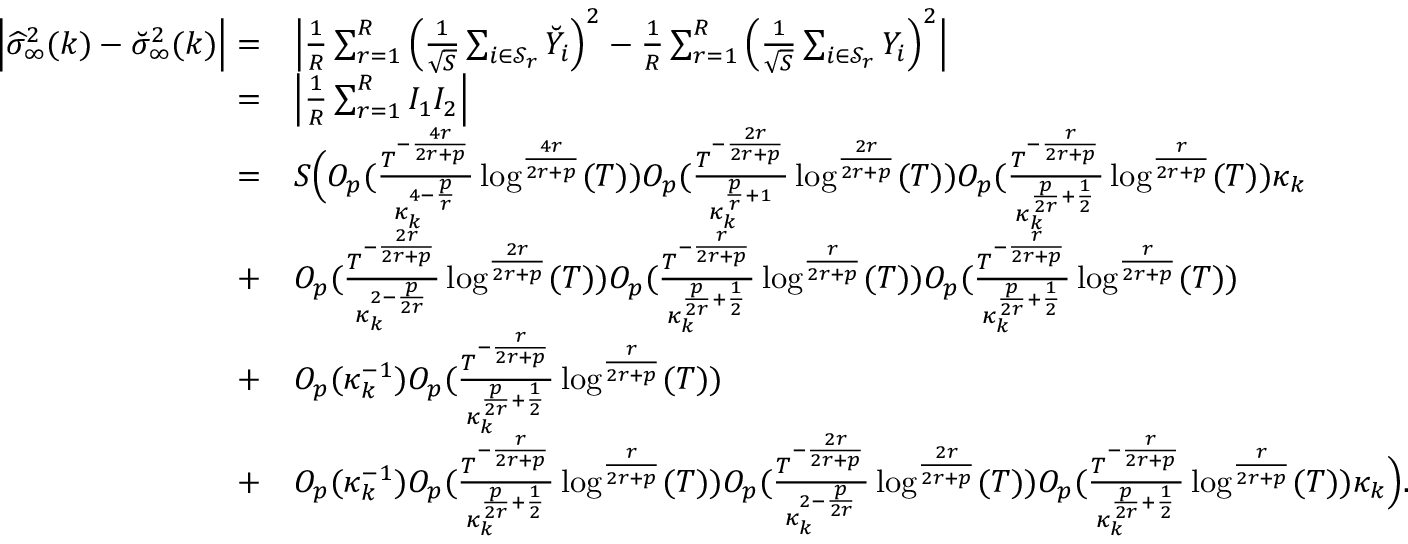<formula> <loc_0><loc_0><loc_500><loc_500>\begin{array} { r l } { \left | \widehat { \sigma } _ { \infty } ^ { 2 } ( k ) - \breve { \sigma } _ { \infty } ^ { 2 } ( k ) \right | = } & { \left | \frac { 1 } { R } \sum _ { r = 1 } ^ { R } \left ( \frac { 1 } { \sqrt { S } } \sum _ { i \in { \mathcal { S } _ { r } } } \breve { Y } _ { i } \right ) ^ { 2 } - \frac { 1 } { R } \sum _ { r = 1 } ^ { R } \left ( \frac { 1 } { \sqrt { S } } \sum _ { i \in { \mathcal { S } _ { r } } } Y _ { i } \right ) ^ { 2 } \right | } \\ { = } & { \left | \frac { 1 } { R } \sum _ { r = 1 } ^ { R } I _ { 1 } I _ { 2 } \right | } \\ { = } & { S \left ( O _ { p } ( \frac { T ^ { - \frac { 4 r } { 2 r + p } } } { \kappa _ { k } ^ { 4 - \frac { p } { r } } } \log ^ { \frac { 4 r } { 2 r + p } } ( T ) ) O _ { p } ( \frac { T ^ { - \frac { 2 r } { 2 r + p } } } { \kappa _ { k } ^ { \frac { p } { r } + 1 } } \log ^ { \frac { 2 r } { 2 r + p } } ( T ) ) O _ { p } ( \frac { T ^ { - \frac { r } { 2 r + p } } } { \kappa _ { k } ^ { \frac { p } { 2 r } + \frac { 1 } { 2 } } } \log ^ { \frac { r } { 2 r + p } } ( T ) ) \kappa _ { k } } \\ { + } & { O _ { p } ( \frac { T ^ { - \frac { 2 r } { 2 r + p } } } { \kappa _ { k } ^ { 2 - \frac { p } { 2 r } } } \log ^ { \frac { 2 r } { 2 r + p } } ( T ) ) O _ { p } ( \frac { T ^ { - \frac { r } { 2 r + p } } } { \kappa _ { k } ^ { \frac { p } { 2 r } + \frac { 1 } { 2 } } } \log ^ { \frac { r } { 2 r + p } } ( T ) ) O _ { p } ( \frac { T ^ { - \frac { r } { 2 r + p } } } { \kappa _ { k } ^ { \frac { p } { 2 r } + \frac { 1 } { 2 } } } \log ^ { \frac { r } { 2 r + p } } ( T ) ) } \\ { + } & { O _ { p } ( \kappa _ { k } ^ { - 1 } ) O _ { p } ( \frac { T ^ { - \frac { r } { 2 r + p } } } { \kappa _ { k } ^ { \frac { p } { 2 r } + \frac { 1 } { 2 } } } \log ^ { \frac { r } { 2 r + p } } ( T ) ) } \\ { + } & { O _ { p } ( \kappa _ { k } ^ { - 1 } ) O _ { p } ( \frac { T ^ { - \frac { r } { 2 r + p } } } { \kappa _ { k } ^ { \frac { p } { 2 r } + \frac { 1 } { 2 } } } \log ^ { \frac { r } { 2 r + p } } ( T ) ) O _ { p } ( \frac { T ^ { - \frac { 2 r } { 2 r + p } } } { \kappa _ { k } ^ { 2 - \frac { p } { 2 r } } } \log ^ { \frac { 2 r } { 2 r + p } } ( T ) ) O _ { p } ( \frac { T ^ { - \frac { r } { 2 r + p } } } { \kappa _ { k } ^ { \frac { p } { 2 r } + \frac { 1 } { 2 } } } \log ^ { \frac { r } { 2 r + p } } ( T ) ) \kappa _ { k } \right ) . } \end{array}</formula> 